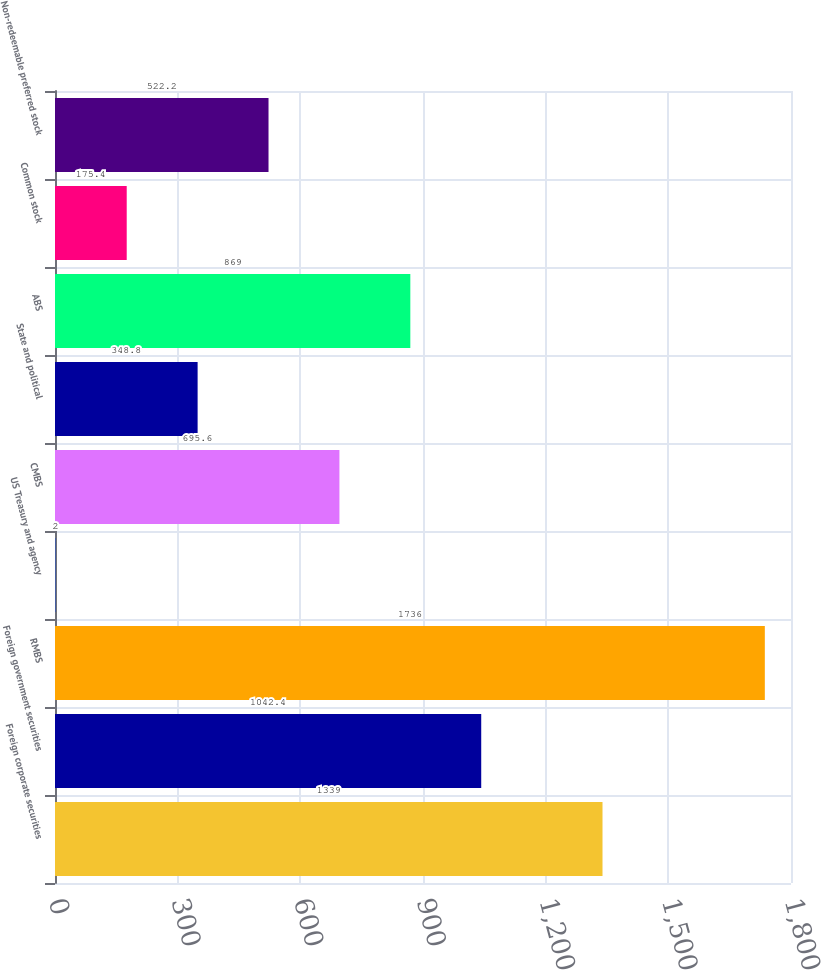<chart> <loc_0><loc_0><loc_500><loc_500><bar_chart><fcel>Foreign corporate securities<fcel>Foreign government securities<fcel>RMBS<fcel>US Treasury and agency<fcel>CMBS<fcel>State and political<fcel>ABS<fcel>Common stock<fcel>Non-redeemable preferred stock<nl><fcel>1339<fcel>1042.4<fcel>1736<fcel>2<fcel>695.6<fcel>348.8<fcel>869<fcel>175.4<fcel>522.2<nl></chart> 